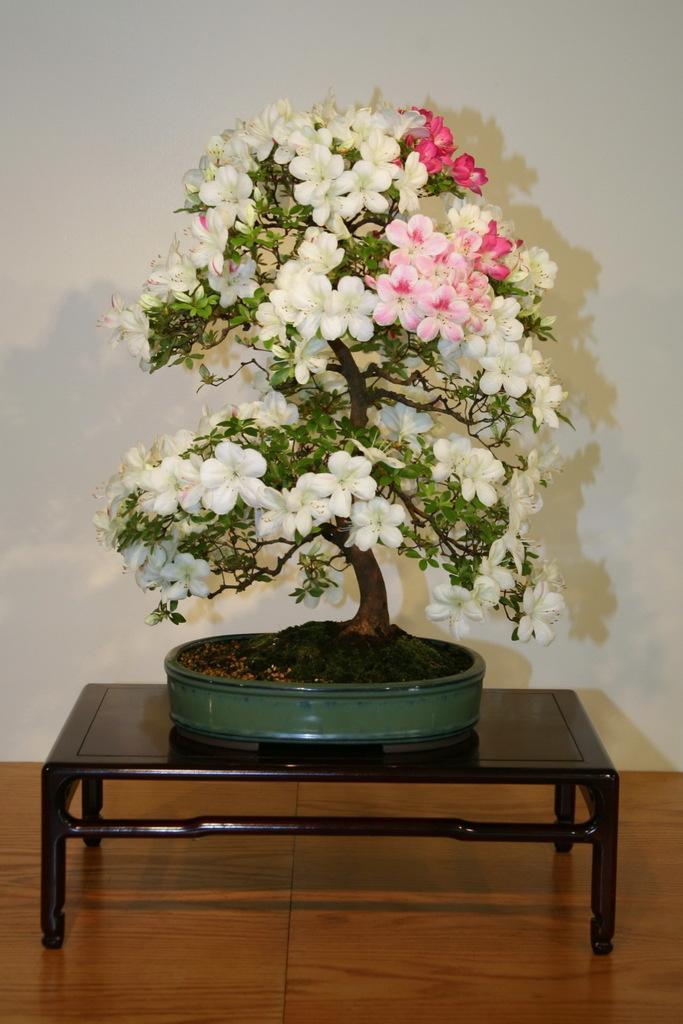Describe this image in one or two sentences. As we can see in the image there is a white color wall and a small table. On table there is a plant. 